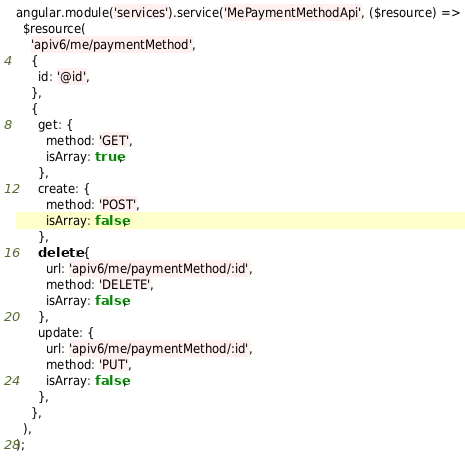<code> <loc_0><loc_0><loc_500><loc_500><_JavaScript_>angular.module('services').service('MePaymentMethodApi', ($resource) =>
  $resource(
    'apiv6/me/paymentMethod',
    {
      id: '@id',
    },
    {
      get: {
        method: 'GET',
        isArray: true,
      },
      create: {
        method: 'POST',
        isArray: false,
      },
      delete: {
        url: 'apiv6/me/paymentMethod/:id',
        method: 'DELETE',
        isArray: false,
      },
      update: {
        url: 'apiv6/me/paymentMethod/:id',
        method: 'PUT',
        isArray: false,
      },
    },
  ),
);
</code> 